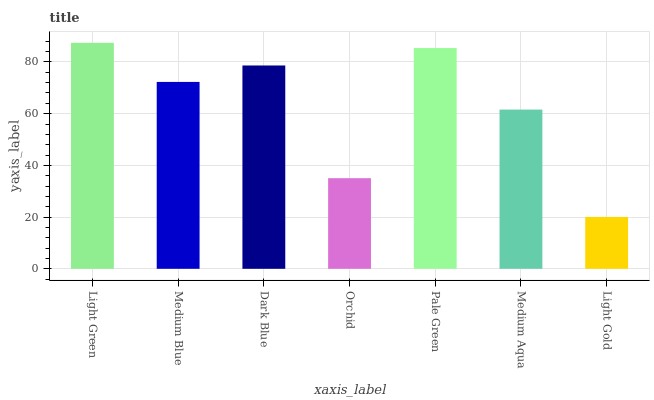Is Light Gold the minimum?
Answer yes or no. Yes. Is Light Green the maximum?
Answer yes or no. Yes. Is Medium Blue the minimum?
Answer yes or no. No. Is Medium Blue the maximum?
Answer yes or no. No. Is Light Green greater than Medium Blue?
Answer yes or no. Yes. Is Medium Blue less than Light Green?
Answer yes or no. Yes. Is Medium Blue greater than Light Green?
Answer yes or no. No. Is Light Green less than Medium Blue?
Answer yes or no. No. Is Medium Blue the high median?
Answer yes or no. Yes. Is Medium Blue the low median?
Answer yes or no. Yes. Is Light Gold the high median?
Answer yes or no. No. Is Light Green the low median?
Answer yes or no. No. 